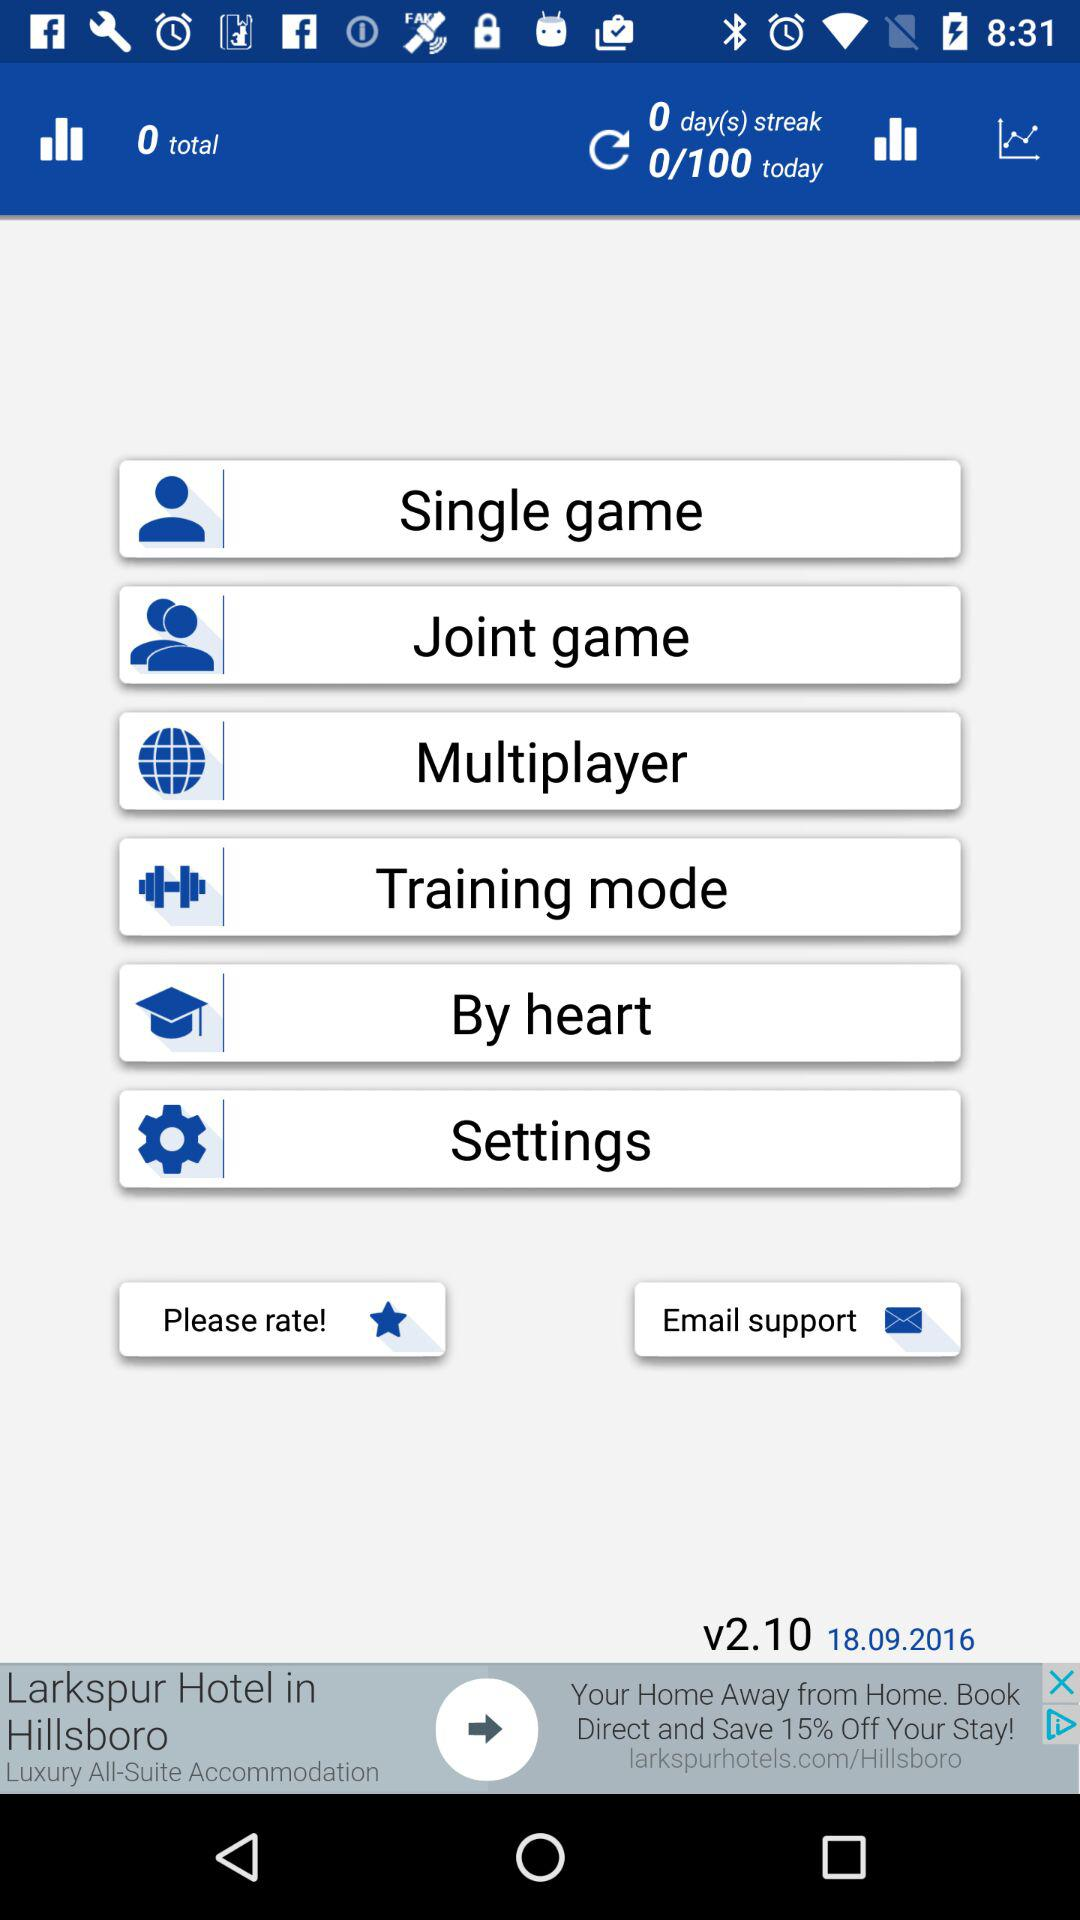What is the total? The total is 0. 